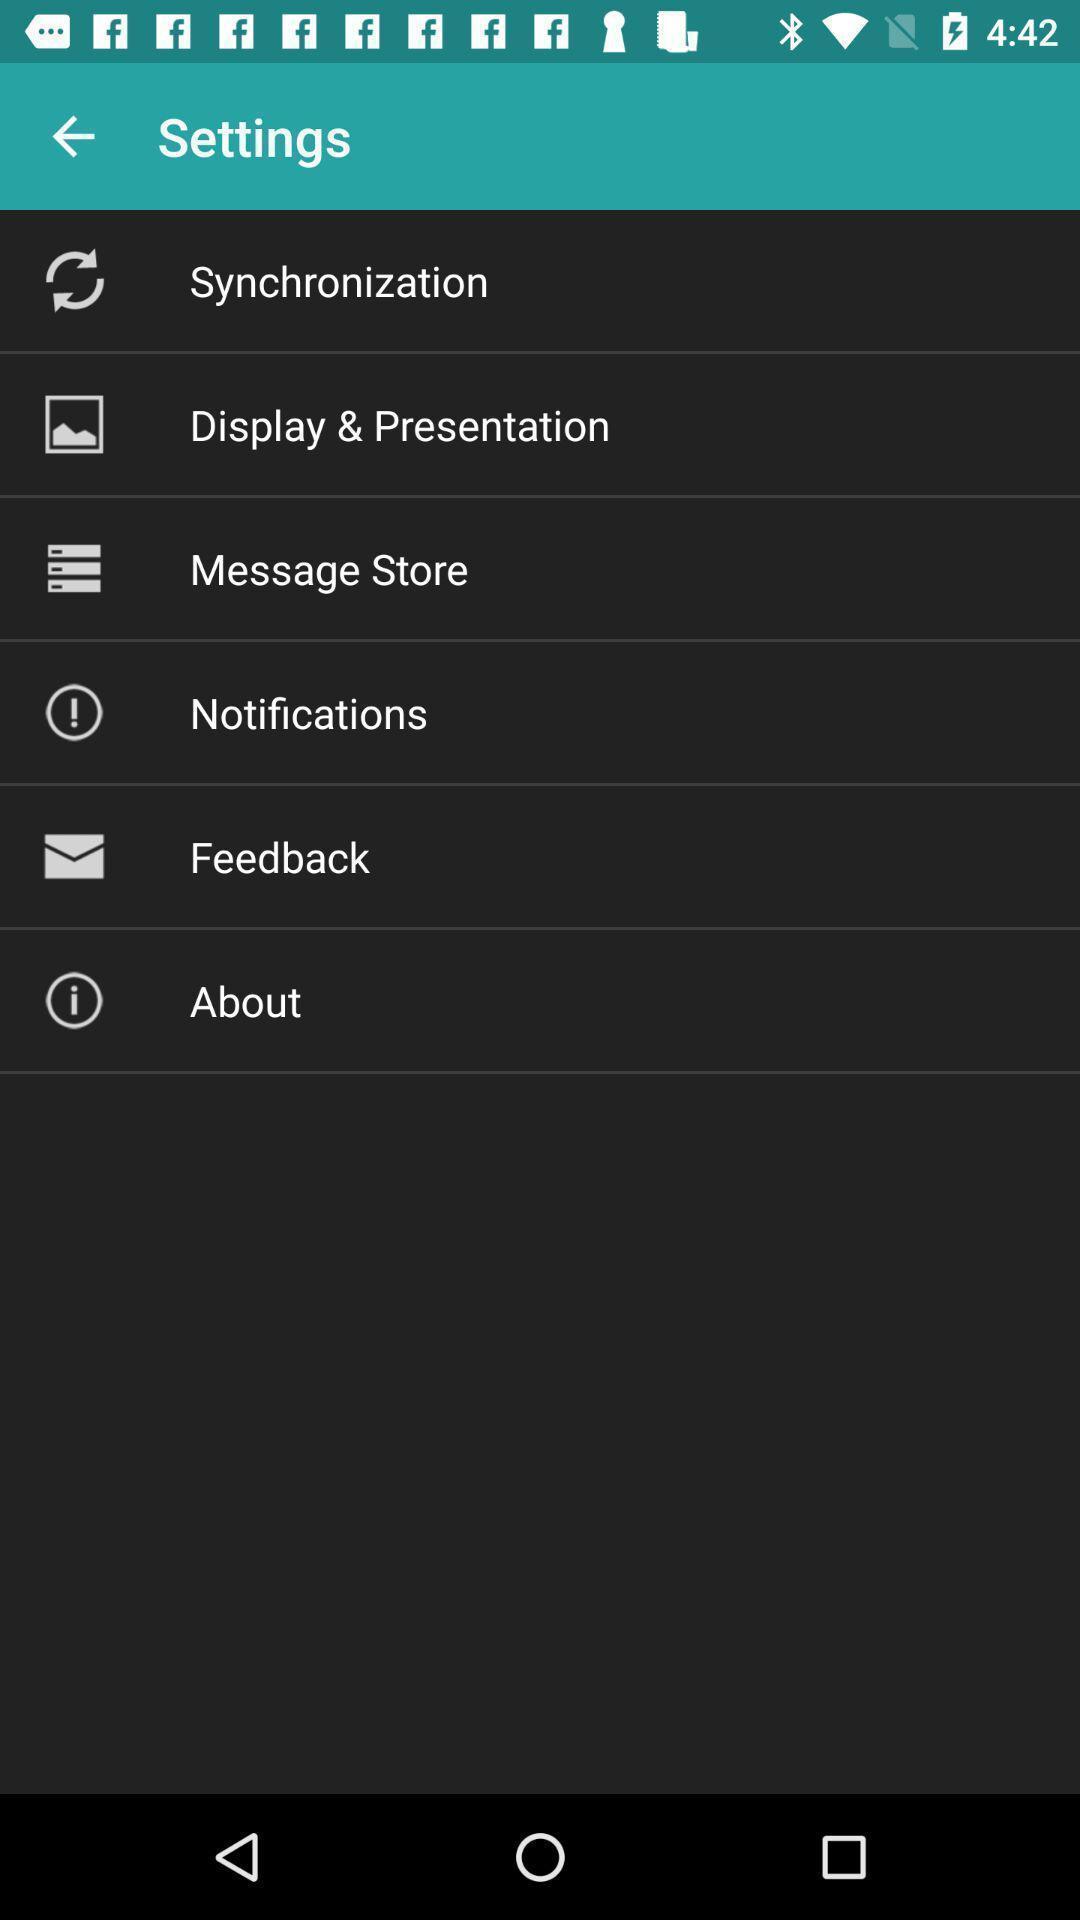Tell me about the visual elements in this screen capture. Settings page. 